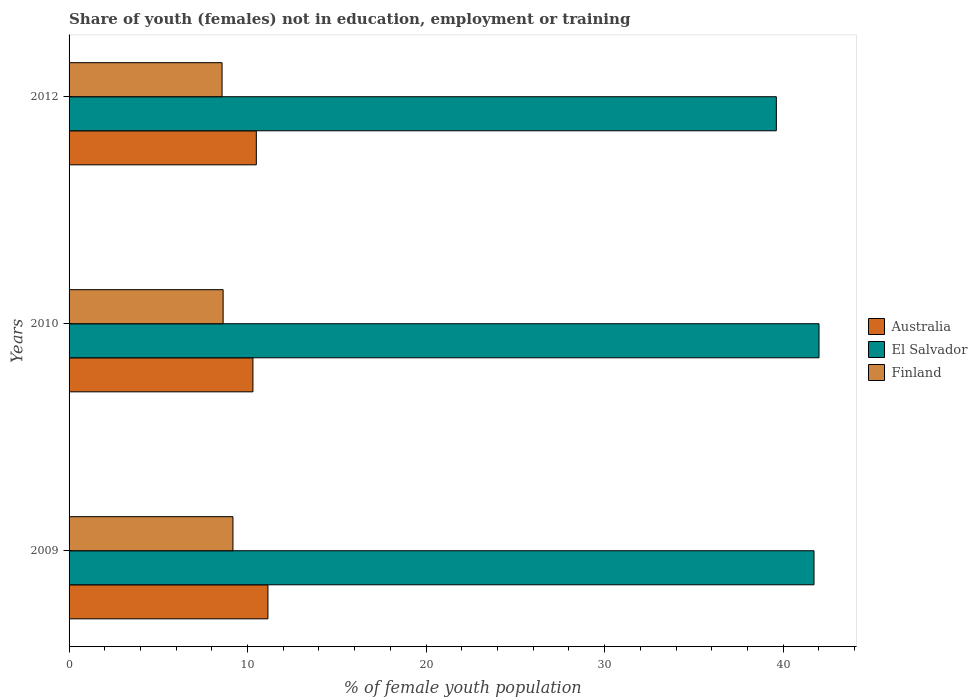How many bars are there on the 2nd tick from the top?
Make the answer very short. 3. How many bars are there on the 3rd tick from the bottom?
Keep it short and to the point. 3. What is the label of the 3rd group of bars from the top?
Ensure brevity in your answer.  2009. In how many cases, is the number of bars for a given year not equal to the number of legend labels?
Keep it short and to the point. 0. What is the percentage of unemployed female population in in Finland in 2010?
Offer a terse response. 8.63. Across all years, what is the maximum percentage of unemployed female population in in El Salvador?
Ensure brevity in your answer.  42.01. Across all years, what is the minimum percentage of unemployed female population in in El Salvador?
Offer a terse response. 39.62. What is the total percentage of unemployed female population in in El Salvador in the graph?
Your answer should be compact. 123.36. What is the difference between the percentage of unemployed female population in in Australia in 2009 and that in 2010?
Ensure brevity in your answer.  0.84. What is the difference between the percentage of unemployed female population in in Finland in 2009 and the percentage of unemployed female population in in El Salvador in 2012?
Keep it short and to the point. -30.44. What is the average percentage of unemployed female population in in Finland per year?
Your response must be concise. 8.79. In the year 2009, what is the difference between the percentage of unemployed female population in in El Salvador and percentage of unemployed female population in in Australia?
Provide a succinct answer. 30.59. What is the ratio of the percentage of unemployed female population in in El Salvador in 2009 to that in 2012?
Provide a succinct answer. 1.05. What is the difference between the highest and the second highest percentage of unemployed female population in in Australia?
Give a very brief answer. 0.65. What is the difference between the highest and the lowest percentage of unemployed female population in in Australia?
Make the answer very short. 0.84. In how many years, is the percentage of unemployed female population in in Australia greater than the average percentage of unemployed female population in in Australia taken over all years?
Provide a succinct answer. 1. What does the 1st bar from the top in 2010 represents?
Ensure brevity in your answer.  Finland. What does the 1st bar from the bottom in 2012 represents?
Your response must be concise. Australia. Are all the bars in the graph horizontal?
Make the answer very short. Yes. What is the difference between two consecutive major ticks on the X-axis?
Offer a very short reply. 10. Are the values on the major ticks of X-axis written in scientific E-notation?
Your response must be concise. No. Does the graph contain any zero values?
Offer a terse response. No. What is the title of the graph?
Your answer should be very brief. Share of youth (females) not in education, employment or training. Does "Oman" appear as one of the legend labels in the graph?
Your response must be concise. No. What is the label or title of the X-axis?
Give a very brief answer. % of female youth population. What is the % of female youth population in Australia in 2009?
Provide a short and direct response. 11.14. What is the % of female youth population of El Salvador in 2009?
Your answer should be very brief. 41.73. What is the % of female youth population of Finland in 2009?
Your response must be concise. 9.18. What is the % of female youth population in Australia in 2010?
Provide a short and direct response. 10.3. What is the % of female youth population of El Salvador in 2010?
Your answer should be very brief. 42.01. What is the % of female youth population of Finland in 2010?
Offer a very short reply. 8.63. What is the % of female youth population in Australia in 2012?
Ensure brevity in your answer.  10.49. What is the % of female youth population of El Salvador in 2012?
Your answer should be very brief. 39.62. What is the % of female youth population in Finland in 2012?
Give a very brief answer. 8.57. Across all years, what is the maximum % of female youth population in Australia?
Ensure brevity in your answer.  11.14. Across all years, what is the maximum % of female youth population of El Salvador?
Provide a short and direct response. 42.01. Across all years, what is the maximum % of female youth population in Finland?
Ensure brevity in your answer.  9.18. Across all years, what is the minimum % of female youth population in Australia?
Keep it short and to the point. 10.3. Across all years, what is the minimum % of female youth population in El Salvador?
Offer a terse response. 39.62. Across all years, what is the minimum % of female youth population in Finland?
Give a very brief answer. 8.57. What is the total % of female youth population of Australia in the graph?
Provide a succinct answer. 31.93. What is the total % of female youth population of El Salvador in the graph?
Make the answer very short. 123.36. What is the total % of female youth population in Finland in the graph?
Your response must be concise. 26.38. What is the difference between the % of female youth population in Australia in 2009 and that in 2010?
Your response must be concise. 0.84. What is the difference between the % of female youth population of El Salvador in 2009 and that in 2010?
Give a very brief answer. -0.28. What is the difference between the % of female youth population in Finland in 2009 and that in 2010?
Give a very brief answer. 0.55. What is the difference between the % of female youth population of Australia in 2009 and that in 2012?
Provide a short and direct response. 0.65. What is the difference between the % of female youth population of El Salvador in 2009 and that in 2012?
Offer a terse response. 2.11. What is the difference between the % of female youth population in Finland in 2009 and that in 2012?
Keep it short and to the point. 0.61. What is the difference between the % of female youth population of Australia in 2010 and that in 2012?
Keep it short and to the point. -0.19. What is the difference between the % of female youth population of El Salvador in 2010 and that in 2012?
Keep it short and to the point. 2.39. What is the difference between the % of female youth population in Finland in 2010 and that in 2012?
Offer a very short reply. 0.06. What is the difference between the % of female youth population of Australia in 2009 and the % of female youth population of El Salvador in 2010?
Keep it short and to the point. -30.87. What is the difference between the % of female youth population of Australia in 2009 and the % of female youth population of Finland in 2010?
Your response must be concise. 2.51. What is the difference between the % of female youth population of El Salvador in 2009 and the % of female youth population of Finland in 2010?
Offer a very short reply. 33.1. What is the difference between the % of female youth population of Australia in 2009 and the % of female youth population of El Salvador in 2012?
Your answer should be very brief. -28.48. What is the difference between the % of female youth population of Australia in 2009 and the % of female youth population of Finland in 2012?
Make the answer very short. 2.57. What is the difference between the % of female youth population of El Salvador in 2009 and the % of female youth population of Finland in 2012?
Provide a short and direct response. 33.16. What is the difference between the % of female youth population in Australia in 2010 and the % of female youth population in El Salvador in 2012?
Offer a terse response. -29.32. What is the difference between the % of female youth population in Australia in 2010 and the % of female youth population in Finland in 2012?
Your answer should be very brief. 1.73. What is the difference between the % of female youth population in El Salvador in 2010 and the % of female youth population in Finland in 2012?
Provide a short and direct response. 33.44. What is the average % of female youth population of Australia per year?
Offer a very short reply. 10.64. What is the average % of female youth population of El Salvador per year?
Ensure brevity in your answer.  41.12. What is the average % of female youth population in Finland per year?
Ensure brevity in your answer.  8.79. In the year 2009, what is the difference between the % of female youth population in Australia and % of female youth population in El Salvador?
Your answer should be very brief. -30.59. In the year 2009, what is the difference between the % of female youth population in Australia and % of female youth population in Finland?
Your response must be concise. 1.96. In the year 2009, what is the difference between the % of female youth population in El Salvador and % of female youth population in Finland?
Provide a short and direct response. 32.55. In the year 2010, what is the difference between the % of female youth population in Australia and % of female youth population in El Salvador?
Ensure brevity in your answer.  -31.71. In the year 2010, what is the difference between the % of female youth population of Australia and % of female youth population of Finland?
Offer a very short reply. 1.67. In the year 2010, what is the difference between the % of female youth population in El Salvador and % of female youth population in Finland?
Provide a short and direct response. 33.38. In the year 2012, what is the difference between the % of female youth population in Australia and % of female youth population in El Salvador?
Your answer should be very brief. -29.13. In the year 2012, what is the difference between the % of female youth population in Australia and % of female youth population in Finland?
Offer a very short reply. 1.92. In the year 2012, what is the difference between the % of female youth population in El Salvador and % of female youth population in Finland?
Your answer should be very brief. 31.05. What is the ratio of the % of female youth population in Australia in 2009 to that in 2010?
Provide a succinct answer. 1.08. What is the ratio of the % of female youth population in El Salvador in 2009 to that in 2010?
Provide a succinct answer. 0.99. What is the ratio of the % of female youth population of Finland in 2009 to that in 2010?
Ensure brevity in your answer.  1.06. What is the ratio of the % of female youth population of Australia in 2009 to that in 2012?
Your answer should be very brief. 1.06. What is the ratio of the % of female youth population in El Salvador in 2009 to that in 2012?
Ensure brevity in your answer.  1.05. What is the ratio of the % of female youth population of Finland in 2009 to that in 2012?
Offer a very short reply. 1.07. What is the ratio of the % of female youth population in Australia in 2010 to that in 2012?
Your answer should be very brief. 0.98. What is the ratio of the % of female youth population in El Salvador in 2010 to that in 2012?
Ensure brevity in your answer.  1.06. What is the ratio of the % of female youth population of Finland in 2010 to that in 2012?
Your answer should be very brief. 1.01. What is the difference between the highest and the second highest % of female youth population in Australia?
Offer a very short reply. 0.65. What is the difference between the highest and the second highest % of female youth population of El Salvador?
Make the answer very short. 0.28. What is the difference between the highest and the second highest % of female youth population in Finland?
Offer a very short reply. 0.55. What is the difference between the highest and the lowest % of female youth population in Australia?
Ensure brevity in your answer.  0.84. What is the difference between the highest and the lowest % of female youth population of El Salvador?
Offer a very short reply. 2.39. What is the difference between the highest and the lowest % of female youth population in Finland?
Your answer should be very brief. 0.61. 